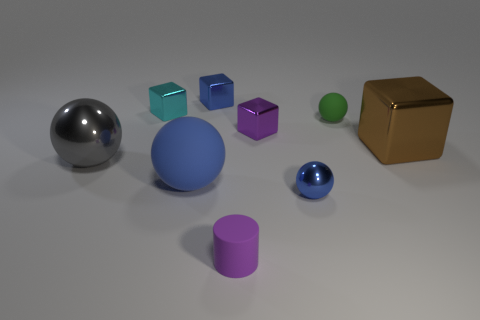Are there fewer big objects left of the big gray ball than big brown objects that are behind the blue metal cube?
Provide a succinct answer. No. The other big metallic object that is the same shape as the cyan thing is what color?
Give a very brief answer. Brown. There is a shiny cube that is behind the cyan shiny thing; does it have the same size as the large brown metallic block?
Your answer should be very brief. No. Is the number of blue shiny balls behind the tiny green object less than the number of tiny purple things?
Ensure brevity in your answer.  Yes. Are there any other things that are the same size as the blue matte thing?
Your response must be concise. Yes. How big is the purple object that is in front of the ball left of the small cyan metal thing?
Ensure brevity in your answer.  Small. Is there any other thing that has the same shape as the cyan object?
Your answer should be very brief. Yes. Are there fewer small red rubber things than blue things?
Keep it short and to the point. Yes. What is the material of the thing that is both left of the big matte object and behind the green rubber object?
Offer a terse response. Metal. Is there a ball behind the matte sphere behind the large brown metal object?
Ensure brevity in your answer.  No. 